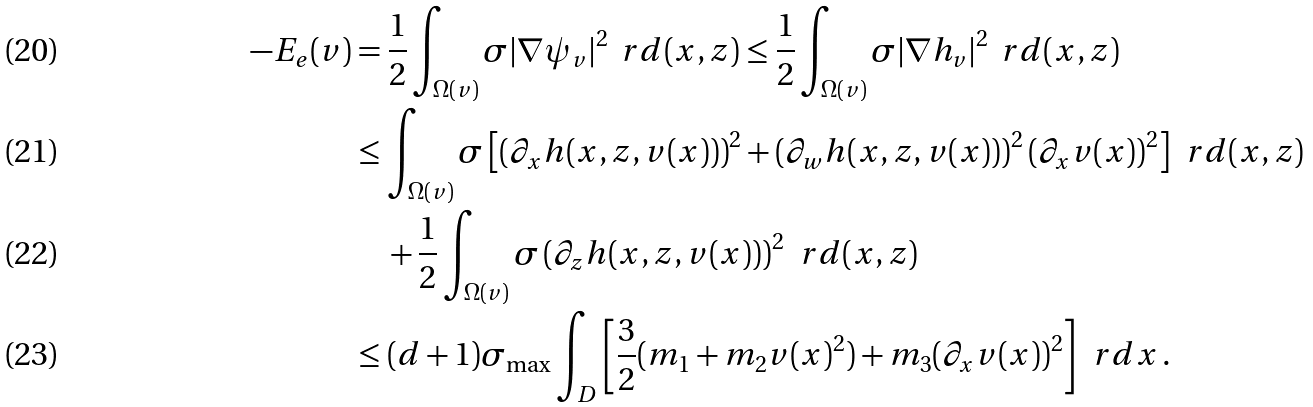Convert formula to latex. <formula><loc_0><loc_0><loc_500><loc_500>- E _ { e } ( v ) & = \frac { 1 } { 2 } \int _ { \Omega ( v ) } \sigma | \nabla \psi _ { v } | ^ { 2 } \, \ r d ( x , z ) \leq \frac { 1 } { 2 } \int _ { \Omega ( v ) } \sigma | \nabla h _ { v } | ^ { 2 } \, \ r d ( x , z ) \\ & \leq \int _ { \Omega ( v ) } \sigma \left [ \left ( \partial _ { x } h ( x , z , v ( x ) ) \right ) ^ { 2 } + \left ( \partial _ { w } h ( x , z , v ( x ) ) \right ) ^ { 2 } ( \partial _ { x } v ( x ) ) ^ { 2 } \right ] \, \ r d ( x , z ) \\ & \quad + \frac { 1 } { 2 } \int _ { \Omega ( v ) } \sigma \left ( \partial _ { z } h ( x , z , v ( x ) ) \right ) ^ { 2 } \, \ r d ( x , z ) \\ & \leq ( d + 1 ) \sigma _ { \max } \int _ { D } \left [ \frac { 3 } { 2 } ( m _ { 1 } + m _ { 2 } v ( x ) ^ { 2 } ) + m _ { 3 } ( \partial _ { x } v ( x ) ) ^ { 2 } \right ] \, \ r d x \, .</formula> 